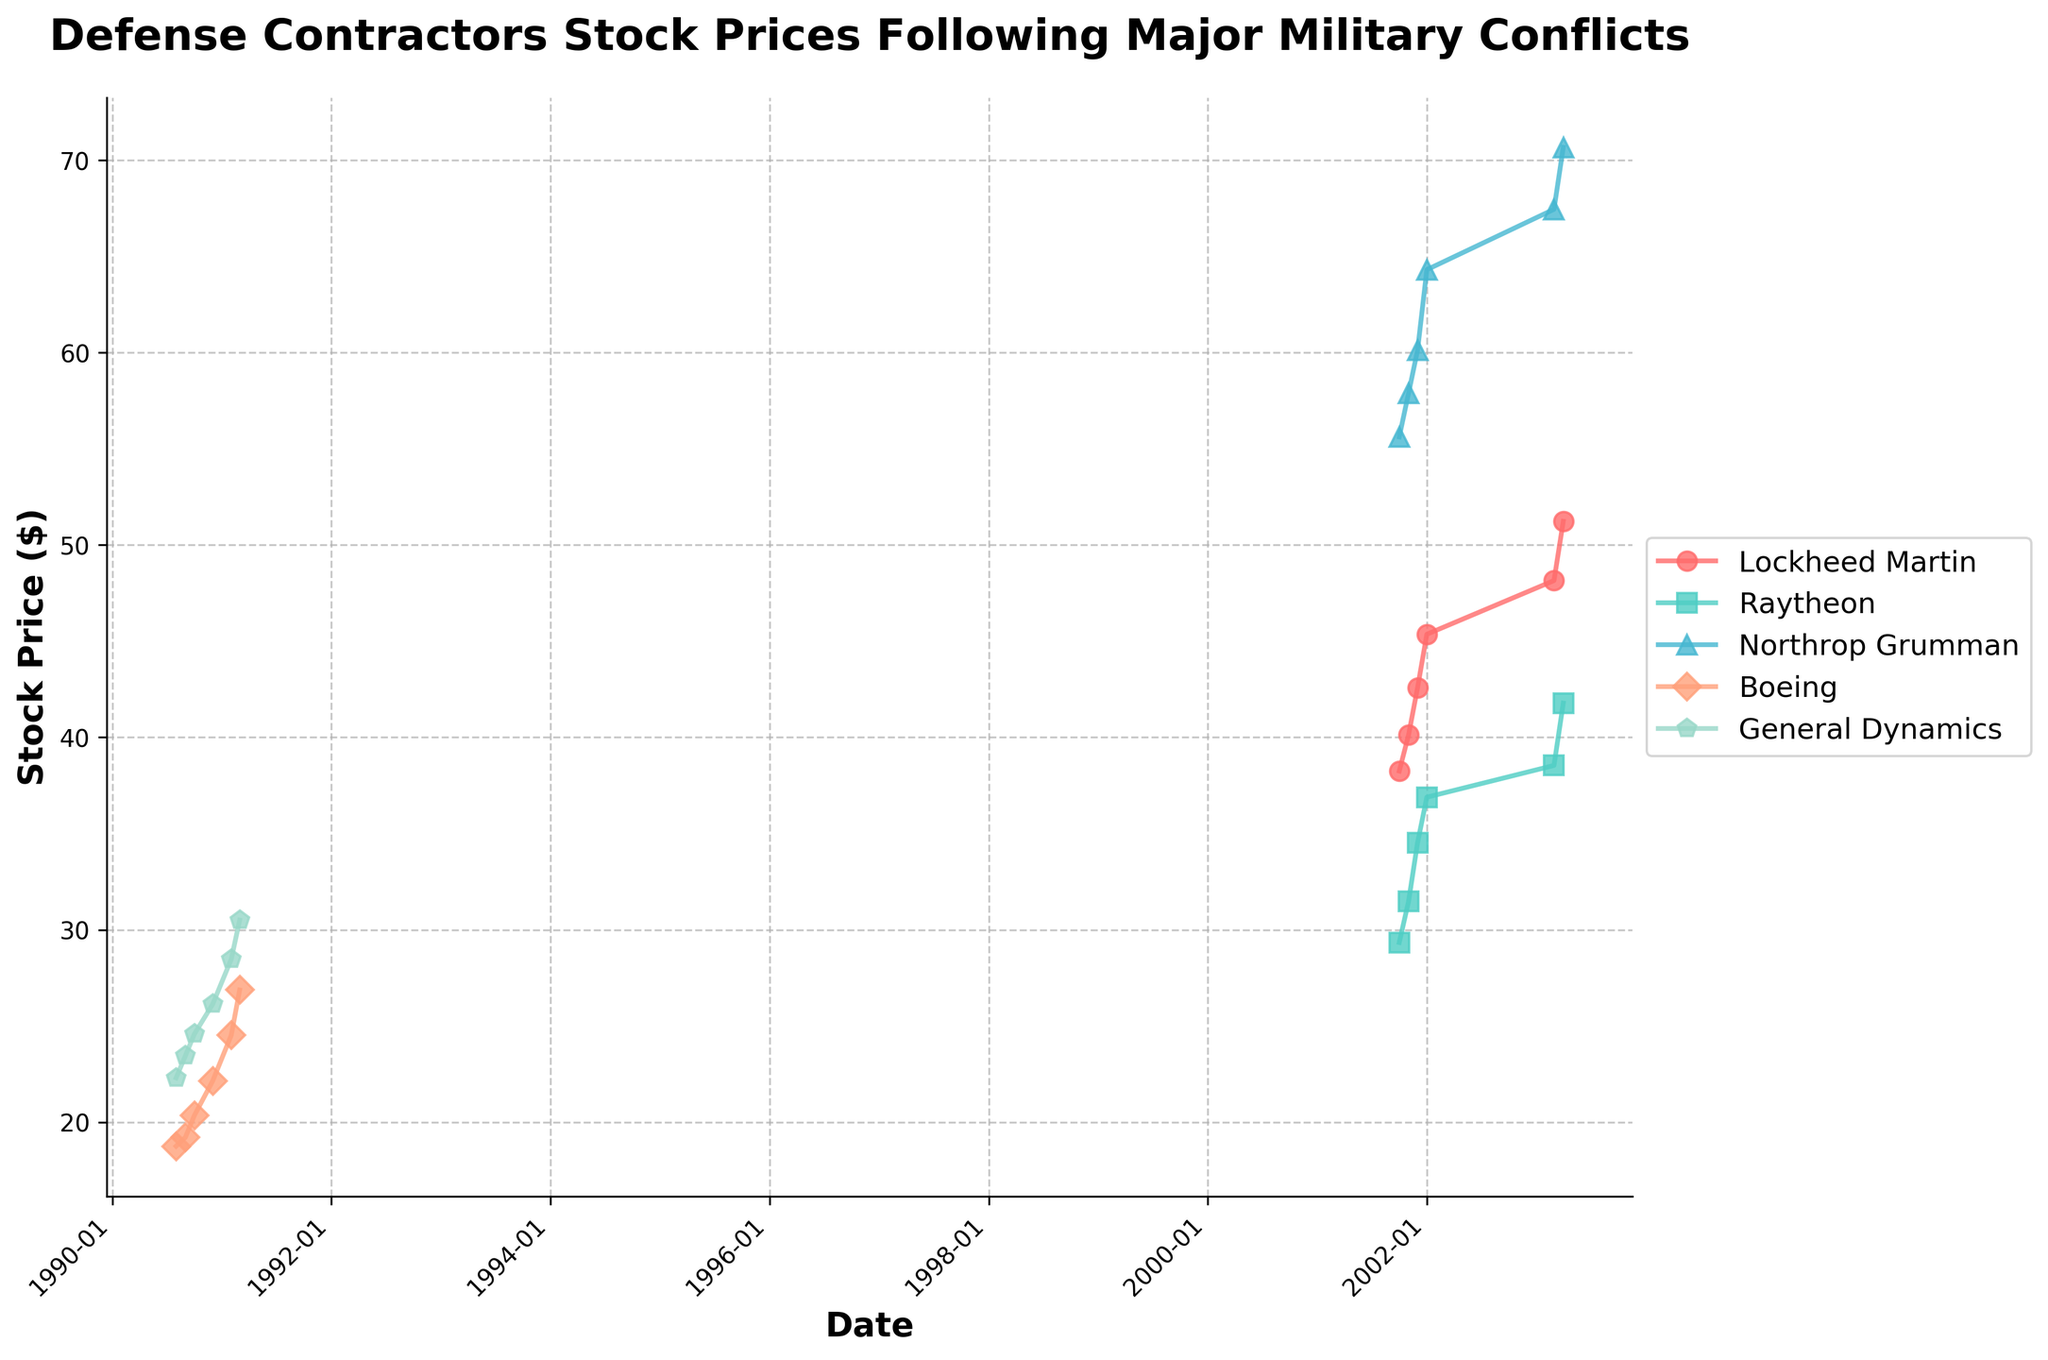Which company had the highest stock price in April 2003? Look at the stock prices in April 2003 for all companies and compare them visually. Lockheed Martin had a stock price of $51.23, Raytheon had $41.78, and Northrop Grumman had $70.67.
Answer: Northrop Grumman How did the stock price of Boeing change from August 1990 to March 1991? Examine Boeing's stock price in August 1990 ($18.75) and March 1991 ($26.87), then calculate the difference: $26.87 - $18.75.
Answer: Increased by $8.12 Which company showed the largest percentage increase in stock price from October 2001 to April 2003? Calculate the percentage increase for each company: Lockheed Martin (($51.23 - $38.25)/$38.25)*100, Raytheon (($41.78 - $29.34)/$29.34)*100, and Northrop Grumman (($70.67 - $55.62)/$55.62)*100. Lockheed Martin: ~33.99%, Raytheon: ~42.37%, Northrop Grumman: ~27.06%.
Answer: Raytheon How many companies' stock prices are shown in the plot? Identify the unique companies listed in the plot. The companies are Lockheed Martin, Raytheon, Northrop Grumman, Boeing, and General Dynamics.
Answer: 5 Which company had a stock price trend that increased every month from October 2001 to April 2003? Check the stock price for each company month by month and see if there are any declines. Lockheed Martin, Raytheon, and Northrop Grumman all have increasing trends without decline in this period.
Answer: Lockheed Martin, Raytheon, Northrop Grumman What was the stock price of General Dynamics in February 1991? Identify the stock price of General Dynamics in February 1991 by referring to the corresponding data point.
Answer: $28.47 How does the overall stock price trend after major military conflicts compare between Lockheed Martin and Raytheon? Observe the lines for Lockheed Martin and Raytheon. Both show an upward trend after October 2001 with general increments each month, though Lockheed Martin's line is slightly steeper.
Answer: Both increased, Lockheed Martin's trend is steeper What was the difference in stock price between Northrop Grumman and Raytheon in December 2001? Find the stock price of Northrop Grumman ($60.12) and Raytheon ($34.52) in December 2001, then calculate the difference: $60.12 - $34.52.
Answer: $25.60 Which company had the smallest stock price in February 1991? Compare the stock prices for all the companies in February 1991. Boeing had $24.52, and General Dynamics had $28.47.
Answer: Boeing 